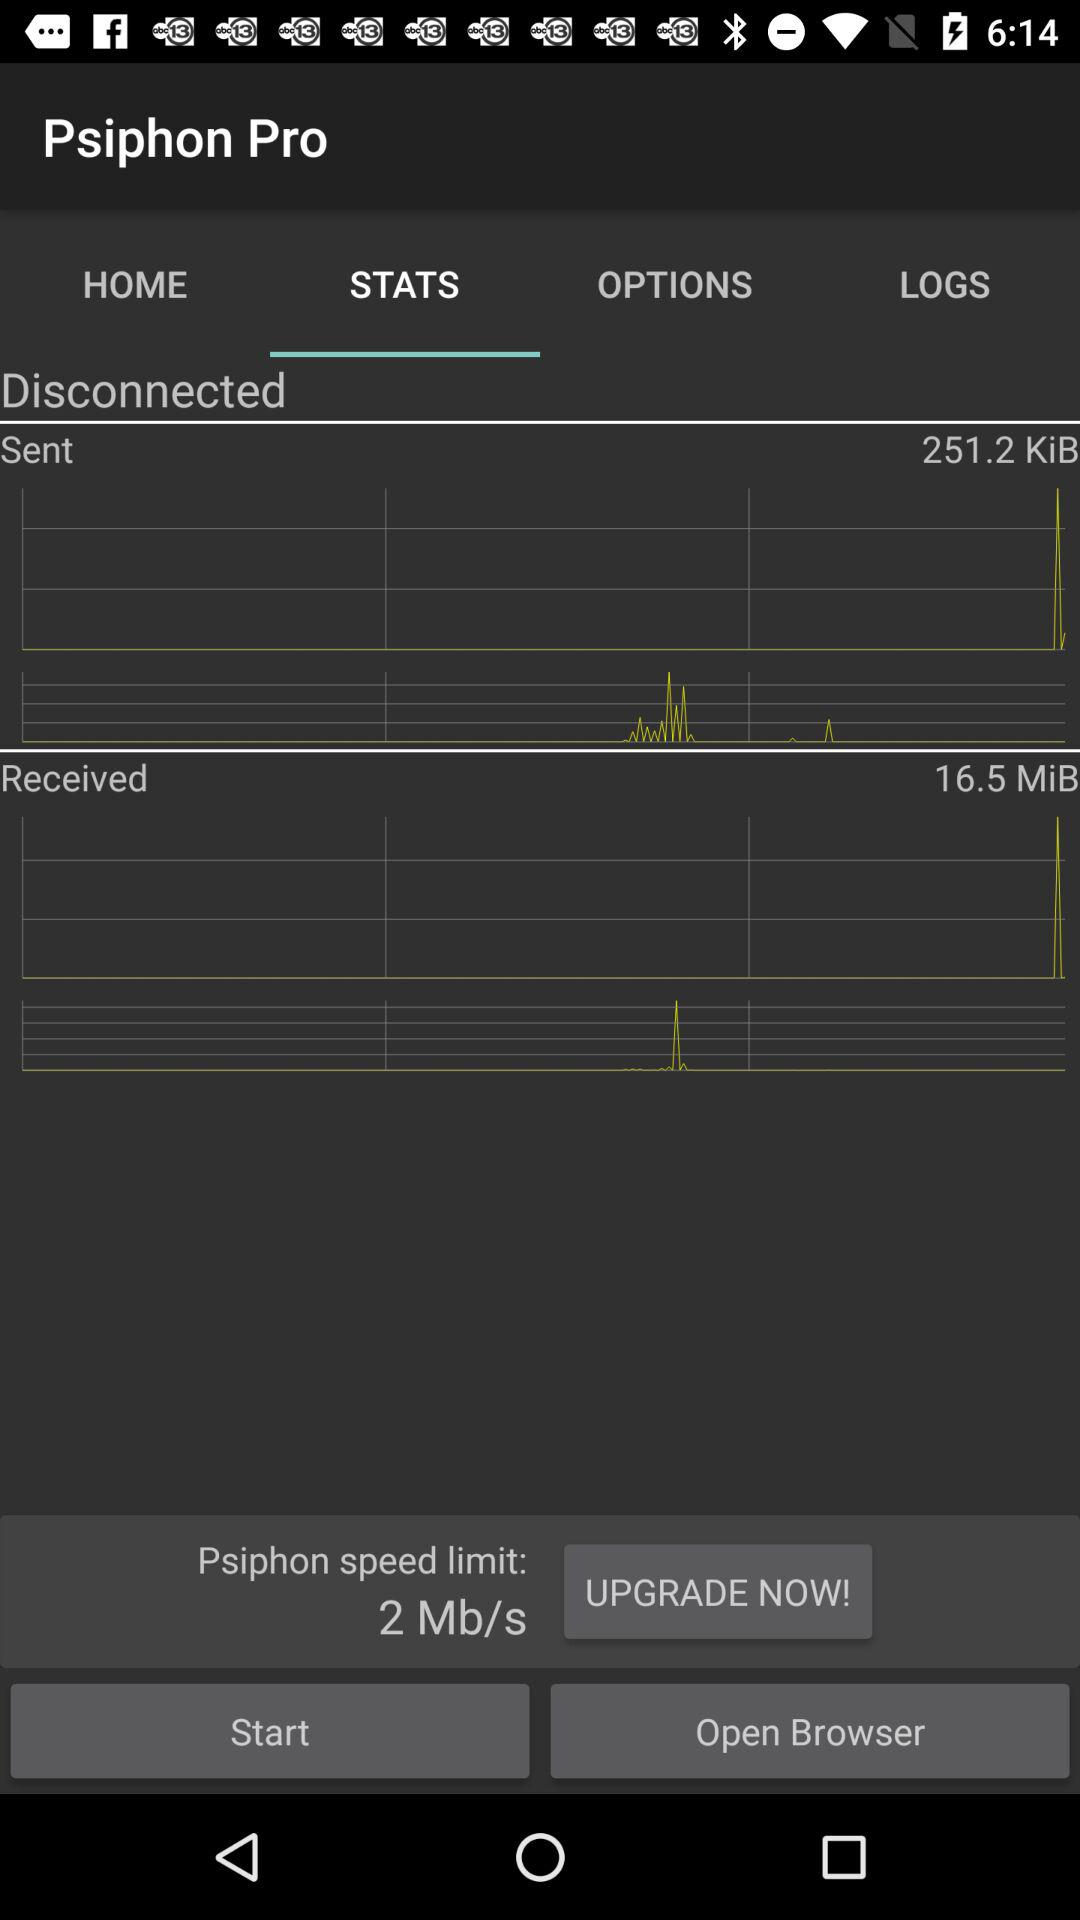What is the speed limit of the Psiphon connection?
Answer the question using a single word or phrase. 2 Mb/s 